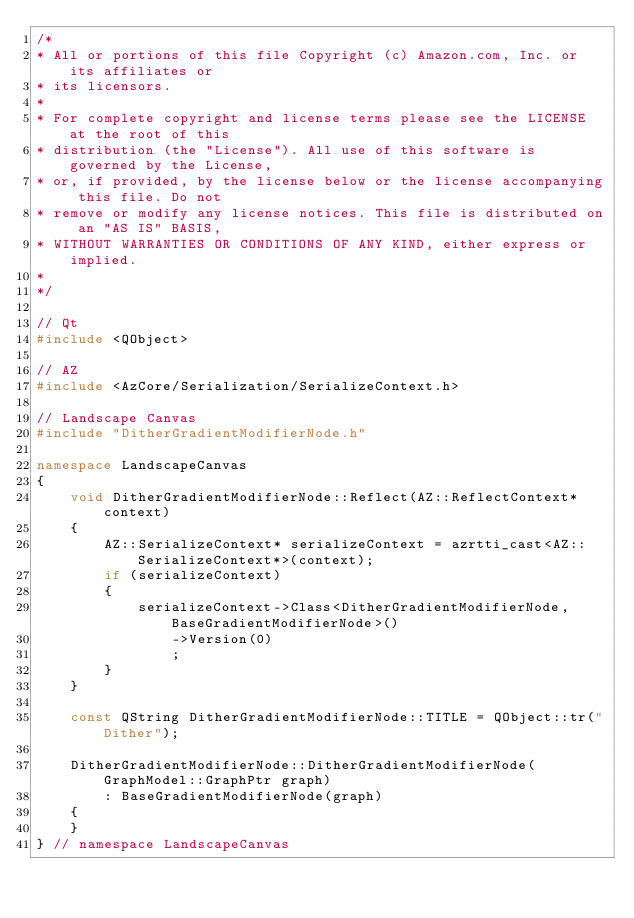<code> <loc_0><loc_0><loc_500><loc_500><_C++_>/*
* All or portions of this file Copyright (c) Amazon.com, Inc. or its affiliates or
* its licensors.
*
* For complete copyright and license terms please see the LICENSE at the root of this
* distribution (the "License"). All use of this software is governed by the License,
* or, if provided, by the license below or the license accompanying this file. Do not
* remove or modify any license notices. This file is distributed on an "AS IS" BASIS,
* WITHOUT WARRANTIES OR CONDITIONS OF ANY KIND, either express or implied.
*
*/

// Qt
#include <QObject>

// AZ
#include <AzCore/Serialization/SerializeContext.h>

// Landscape Canvas
#include "DitherGradientModifierNode.h"

namespace LandscapeCanvas
{
    void DitherGradientModifierNode::Reflect(AZ::ReflectContext* context)
    {
        AZ::SerializeContext* serializeContext = azrtti_cast<AZ::SerializeContext*>(context);
        if (serializeContext)
        {
            serializeContext->Class<DitherGradientModifierNode, BaseGradientModifierNode>()
                ->Version(0)
                ;
        }
    }

    const QString DitherGradientModifierNode::TITLE = QObject::tr("Dither");

    DitherGradientModifierNode::DitherGradientModifierNode(GraphModel::GraphPtr graph)
        : BaseGradientModifierNode(graph)
    {
    }
} // namespace LandscapeCanvas
</code> 